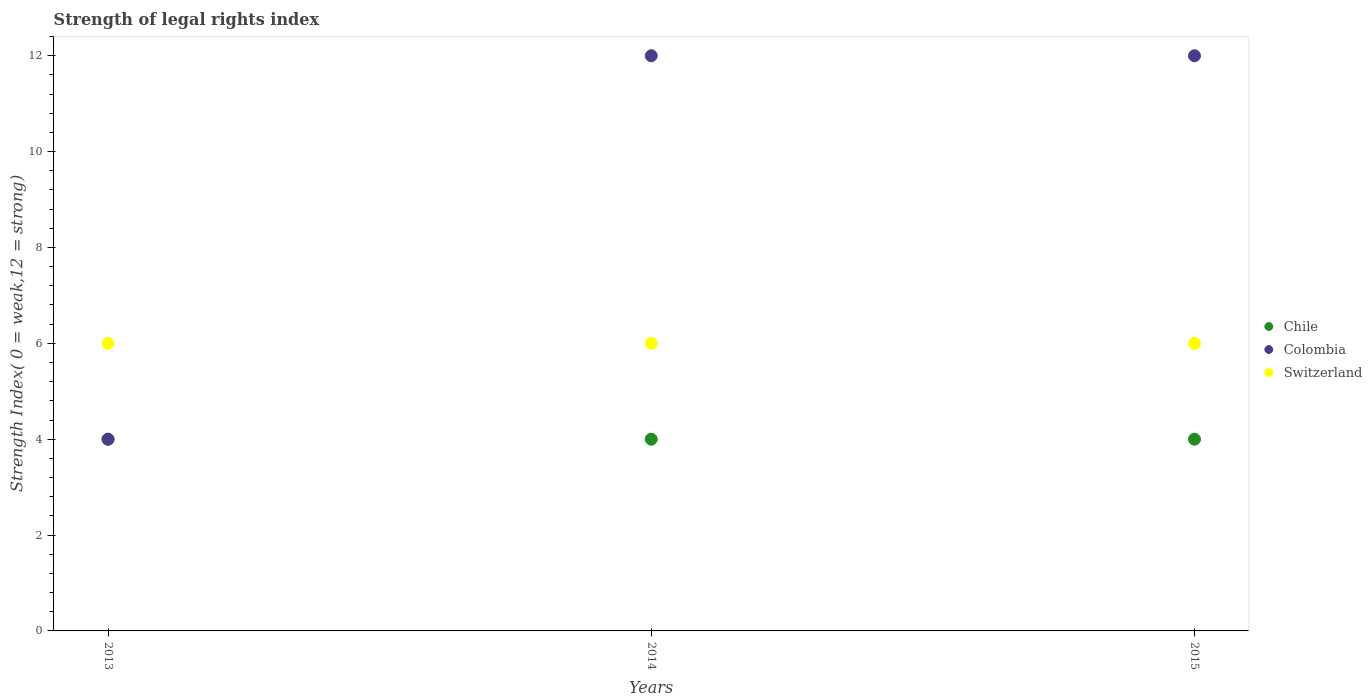How many different coloured dotlines are there?
Provide a short and direct response. 3. Is the number of dotlines equal to the number of legend labels?
Your answer should be very brief. Yes. What is the strength index in Switzerland in 2015?
Offer a terse response. 6. In which year was the strength index in Chile maximum?
Ensure brevity in your answer.  2013. What is the total strength index in Switzerland in the graph?
Your answer should be compact. 18. What is the difference between the strength index in Chile in 2013 and that in 2014?
Ensure brevity in your answer.  0. What is the difference between the strength index in Chile in 2013 and the strength index in Switzerland in 2014?
Your answer should be very brief. -2. In the year 2015, what is the difference between the strength index in Chile and strength index in Colombia?
Make the answer very short. -8. What is the ratio of the strength index in Colombia in 2013 to that in 2014?
Keep it short and to the point. 0.33. Is the difference between the strength index in Chile in 2013 and 2014 greater than the difference between the strength index in Colombia in 2013 and 2014?
Your answer should be compact. Yes. What is the difference between the highest and the second highest strength index in Colombia?
Keep it short and to the point. 0. What is the difference between the highest and the lowest strength index in Colombia?
Provide a short and direct response. 8. In how many years, is the strength index in Switzerland greater than the average strength index in Switzerland taken over all years?
Your answer should be compact. 0. Is it the case that in every year, the sum of the strength index in Switzerland and strength index in Colombia  is greater than the strength index in Chile?
Keep it short and to the point. Yes. Does the strength index in Chile monotonically increase over the years?
Ensure brevity in your answer.  No. Is the strength index in Switzerland strictly greater than the strength index in Colombia over the years?
Keep it short and to the point. No. Is the strength index in Colombia strictly less than the strength index in Chile over the years?
Make the answer very short. No. How many dotlines are there?
Give a very brief answer. 3. How many years are there in the graph?
Your answer should be compact. 3. Does the graph contain grids?
Your response must be concise. No. Where does the legend appear in the graph?
Offer a terse response. Center right. How are the legend labels stacked?
Your answer should be very brief. Vertical. What is the title of the graph?
Ensure brevity in your answer.  Strength of legal rights index. What is the label or title of the Y-axis?
Provide a succinct answer. Strength Index( 0 = weak,12 = strong). What is the Strength Index( 0 = weak,12 = strong) in Chile in 2013?
Make the answer very short. 4. What is the Strength Index( 0 = weak,12 = strong) in Switzerland in 2013?
Give a very brief answer. 6. What is the Strength Index( 0 = weak,12 = strong) of Chile in 2014?
Your answer should be very brief. 4. What is the Strength Index( 0 = weak,12 = strong) in Colombia in 2014?
Your response must be concise. 12. What is the Strength Index( 0 = weak,12 = strong) of Switzerland in 2014?
Offer a terse response. 6. What is the Strength Index( 0 = weak,12 = strong) of Chile in 2015?
Provide a short and direct response. 4. What is the Strength Index( 0 = weak,12 = strong) of Switzerland in 2015?
Give a very brief answer. 6. Across all years, what is the maximum Strength Index( 0 = weak,12 = strong) of Chile?
Give a very brief answer. 4. Across all years, what is the minimum Strength Index( 0 = weak,12 = strong) of Chile?
Provide a short and direct response. 4. Across all years, what is the minimum Strength Index( 0 = weak,12 = strong) of Colombia?
Your answer should be very brief. 4. Across all years, what is the minimum Strength Index( 0 = weak,12 = strong) of Switzerland?
Your answer should be compact. 6. What is the total Strength Index( 0 = weak,12 = strong) in Chile in the graph?
Keep it short and to the point. 12. What is the difference between the Strength Index( 0 = weak,12 = strong) of Switzerland in 2013 and that in 2014?
Offer a very short reply. 0. What is the difference between the Strength Index( 0 = weak,12 = strong) in Chile in 2013 and that in 2015?
Offer a very short reply. 0. What is the difference between the Strength Index( 0 = weak,12 = strong) of Colombia in 2013 and that in 2015?
Provide a succinct answer. -8. What is the difference between the Strength Index( 0 = weak,12 = strong) in Switzerland in 2014 and that in 2015?
Give a very brief answer. 0. What is the difference between the Strength Index( 0 = weak,12 = strong) of Chile in 2013 and the Strength Index( 0 = weak,12 = strong) of Colombia in 2014?
Provide a succinct answer. -8. What is the difference between the Strength Index( 0 = weak,12 = strong) of Chile in 2013 and the Strength Index( 0 = weak,12 = strong) of Switzerland in 2014?
Provide a short and direct response. -2. What is the difference between the Strength Index( 0 = weak,12 = strong) of Chile in 2013 and the Strength Index( 0 = weak,12 = strong) of Switzerland in 2015?
Your response must be concise. -2. What is the difference between the Strength Index( 0 = weak,12 = strong) in Colombia in 2014 and the Strength Index( 0 = weak,12 = strong) in Switzerland in 2015?
Offer a very short reply. 6. What is the average Strength Index( 0 = weak,12 = strong) in Colombia per year?
Offer a very short reply. 9.33. What is the average Strength Index( 0 = weak,12 = strong) of Switzerland per year?
Offer a terse response. 6. In the year 2013, what is the difference between the Strength Index( 0 = weak,12 = strong) in Colombia and Strength Index( 0 = weak,12 = strong) in Switzerland?
Ensure brevity in your answer.  -2. In the year 2014, what is the difference between the Strength Index( 0 = weak,12 = strong) of Chile and Strength Index( 0 = weak,12 = strong) of Colombia?
Offer a terse response. -8. In the year 2014, what is the difference between the Strength Index( 0 = weak,12 = strong) in Chile and Strength Index( 0 = weak,12 = strong) in Switzerland?
Offer a very short reply. -2. In the year 2014, what is the difference between the Strength Index( 0 = weak,12 = strong) in Colombia and Strength Index( 0 = weak,12 = strong) in Switzerland?
Offer a very short reply. 6. In the year 2015, what is the difference between the Strength Index( 0 = weak,12 = strong) of Chile and Strength Index( 0 = weak,12 = strong) of Switzerland?
Ensure brevity in your answer.  -2. In the year 2015, what is the difference between the Strength Index( 0 = weak,12 = strong) of Colombia and Strength Index( 0 = weak,12 = strong) of Switzerland?
Offer a very short reply. 6. What is the ratio of the Strength Index( 0 = weak,12 = strong) in Chile in 2013 to that in 2014?
Keep it short and to the point. 1. What is the ratio of the Strength Index( 0 = weak,12 = strong) of Switzerland in 2013 to that in 2014?
Make the answer very short. 1. What is the ratio of the Strength Index( 0 = weak,12 = strong) of Chile in 2013 to that in 2015?
Make the answer very short. 1. What is the ratio of the Strength Index( 0 = weak,12 = strong) of Chile in 2014 to that in 2015?
Your answer should be compact. 1. What is the ratio of the Strength Index( 0 = weak,12 = strong) of Colombia in 2014 to that in 2015?
Keep it short and to the point. 1. What is the difference between the highest and the second highest Strength Index( 0 = weak,12 = strong) in Switzerland?
Ensure brevity in your answer.  0. What is the difference between the highest and the lowest Strength Index( 0 = weak,12 = strong) in Chile?
Make the answer very short. 0. What is the difference between the highest and the lowest Strength Index( 0 = weak,12 = strong) of Colombia?
Offer a very short reply. 8. 